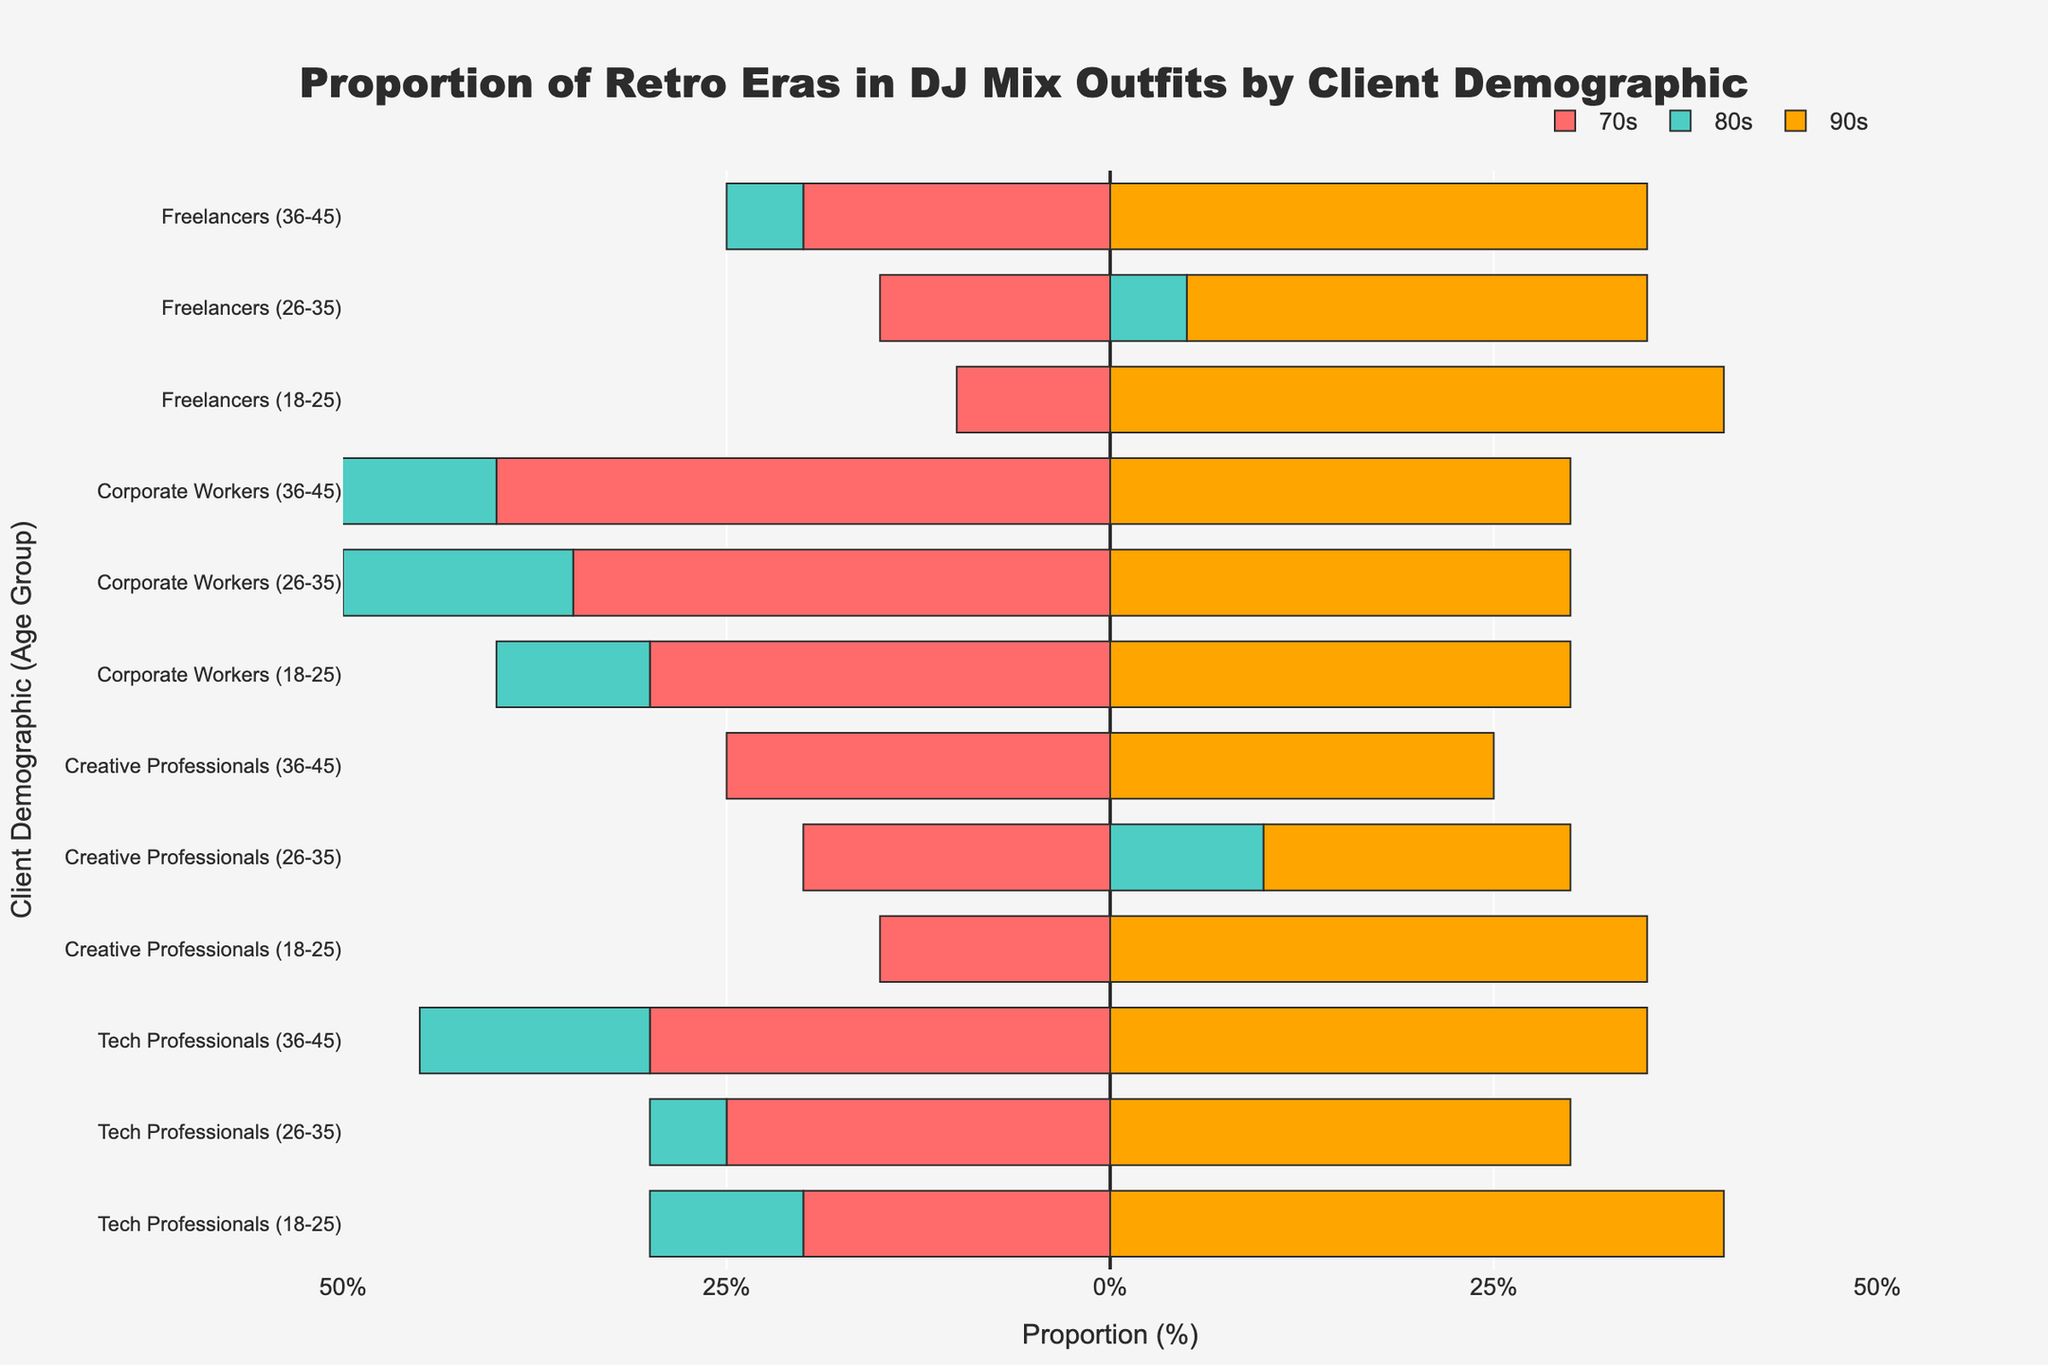Which age group of tech professionals has the highest proportion of 80s outfits? The figure shows the proportion of each era's outfit for different age groups within tech professionals. By looking at the green bars representing the 80s for tech professionals, the 26-35 age group has the highest proportion at 45%.
Answer: 26-35 What is the sum of the proportions of 70s, 80s, and 90s outfits for creative professionals with a college diploma, and how does it compare to those with a master's degree? The sum for creative professionals with a college diploma is 15% (70s) + 50% (80s) + 35% (90s) = 100%. For those with a master's degree, it is 25% (70s) + 50% (80s) + 25% (90s) = 100%. Both sums are equal.
Answer: 100% for both, equal Which demographic has the smallest proportion of 70s outfits and in which age group? By examining the red bars on the left, freelancers aged 18-25 have the smallest proportion at 10%.
Answer: Freelancers, 18-25 Compare the proportion of 90s outfits between corporate workers with a high school diploma and those with a bachelor’s degree. For corporate workers with a high school diploma, the orange bar representing 90s outfits is at 30%, while for those with a bachelor's degree, it is also at 30%. Both age groups have the same proportion.
Answer: Equal at 30% How does the 80s proportion for tech professionals with a bachelor's degree aged 26-35 compare with creative professionals with a bachelor's degree aged 26-35? Tech professionals aged 26-35 have a 45% proportion (green bar), while creative professionals of the same age and education have a 60% proportion. Creative professionals have a higher proportion.
Answer: Creative professionals have a higher proportion What is the average proportion of 90s outfits across all client demographics? Add up the proportions of 90s outfits for each demographic group and divide by the number of groups: (40 + 30 + 35 + 35 + 20 + 25 + 30 + 30 + 30 + 40 + 30 + 35) / 12 = 35%.
Answer: 35% For freelancers with a master’s degree, compare the proportions of outfits from the 70s and 80s. The proportion of 70s outfits (red bar) is 20%, and the proportion of 80s outfits (green bar) is 45%. Therefore, the 80s proportion is higher by 25%.
Answer: 80s higher by 25% Which client demographic and age group has the most balanced distribution of 70s, 80s, and 90s outfits? The most balanced distribution is where the proportions are closest to equal. Tech professionals with a master's degree aged 36-45 have 70s at 30%, 80s at 35%, and 90s at 35%, which is quite balanced.
Answer: Tech professionals, 36-45 How does the proportion of 80s outfits for freelancers aged 26-35 compare to the overall average proportion of 80s outfits for all demographics? Freelancers aged 26-35 have 55% 80s outfits. To find the overall average: (40 + 45 + 35 + 50 + 60 + 50 + 40 + 35 + 30 + 50 + 55 + 45) / 12 = 45.41%. Freelancers aged 26-35 have a higher proportion.
Answer: Higher by 9.59% 